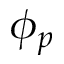Convert formula to latex. <formula><loc_0><loc_0><loc_500><loc_500>\phi _ { p }</formula> 